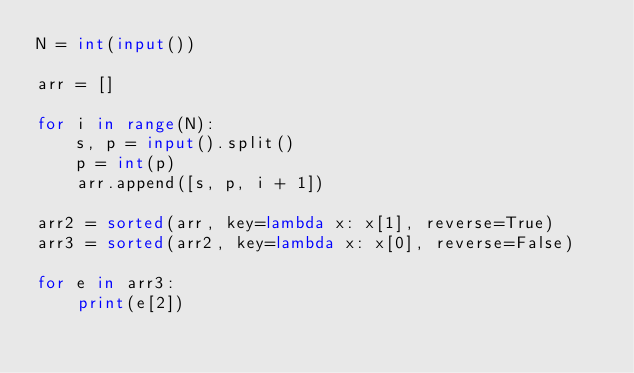Convert code to text. <code><loc_0><loc_0><loc_500><loc_500><_Python_>N = int(input())

arr = []

for i in range(N):
    s, p = input().split()
    p = int(p)
    arr.append([s, p, i + 1])

arr2 = sorted(arr, key=lambda x: x[1], reverse=True)
arr3 = sorted(arr2, key=lambda x: x[0], reverse=False)

for e in arr3:
    print(e[2])
</code> 